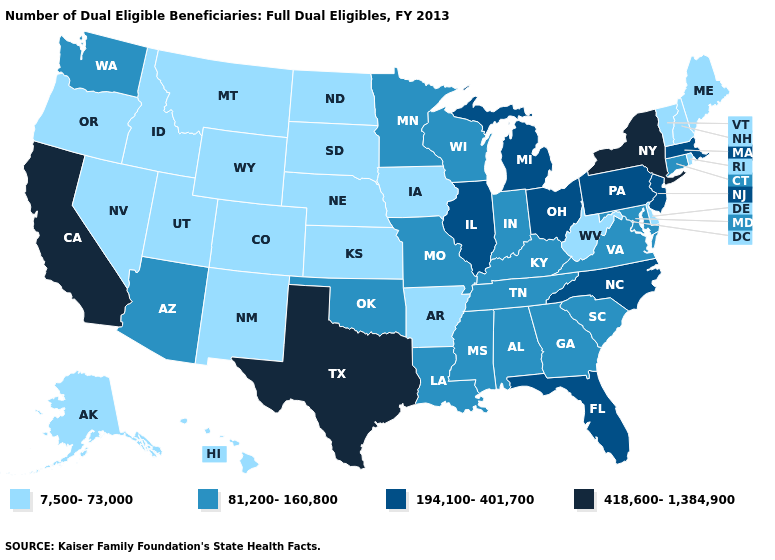What is the highest value in states that border Colorado?
Be succinct. 81,200-160,800. Name the states that have a value in the range 418,600-1,384,900?
Be succinct. California, New York, Texas. Among the states that border Oklahoma , which have the lowest value?
Give a very brief answer. Arkansas, Colorado, Kansas, New Mexico. Does New York have the highest value in the Northeast?
Quick response, please. Yes. What is the highest value in the USA?
Quick response, please. 418,600-1,384,900. Which states have the highest value in the USA?
Answer briefly. California, New York, Texas. Does Mississippi have the same value as North Dakota?
Give a very brief answer. No. Among the states that border Maryland , does West Virginia have the highest value?
Be succinct. No. Does the first symbol in the legend represent the smallest category?
Be succinct. Yes. Which states hav the highest value in the Northeast?
Give a very brief answer. New York. Name the states that have a value in the range 418,600-1,384,900?
Answer briefly. California, New York, Texas. What is the value of Tennessee?
Quick response, please. 81,200-160,800. Among the states that border Delaware , which have the lowest value?
Be succinct. Maryland. Does West Virginia have the lowest value in the South?
Write a very short answer. Yes. Which states have the lowest value in the Northeast?
Quick response, please. Maine, New Hampshire, Rhode Island, Vermont. 